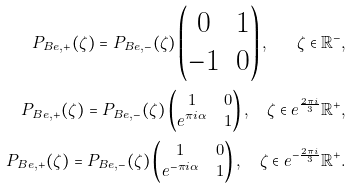Convert formula to latex. <formula><loc_0><loc_0><loc_500><loc_500>P _ { B e , + } ( \zeta ) = P _ { B e , - } ( \zeta ) \begin{pmatrix} 0 & 1 \\ - 1 & 0 \end{pmatrix} , \quad \zeta \in \mathbb { R } ^ { - } , \\ P _ { B e , + } ( \zeta ) = P _ { B e , - } ( \zeta ) \begin{pmatrix} 1 & 0 \\ e ^ { \pi i \alpha } & 1 \end{pmatrix} , \quad \zeta \in e ^ { \frac { 2 \pi i } { 3 } } \mathbb { R } ^ { + } , \\ P _ { B e , + } ( \zeta ) = P _ { B e , - } ( \zeta ) \begin{pmatrix} 1 & 0 \\ e ^ { - \pi i \alpha } & 1 \end{pmatrix} , \quad \zeta \in e ^ { - \frac { 2 \pi i } { 3 } } \mathbb { R } ^ { + } .</formula> 